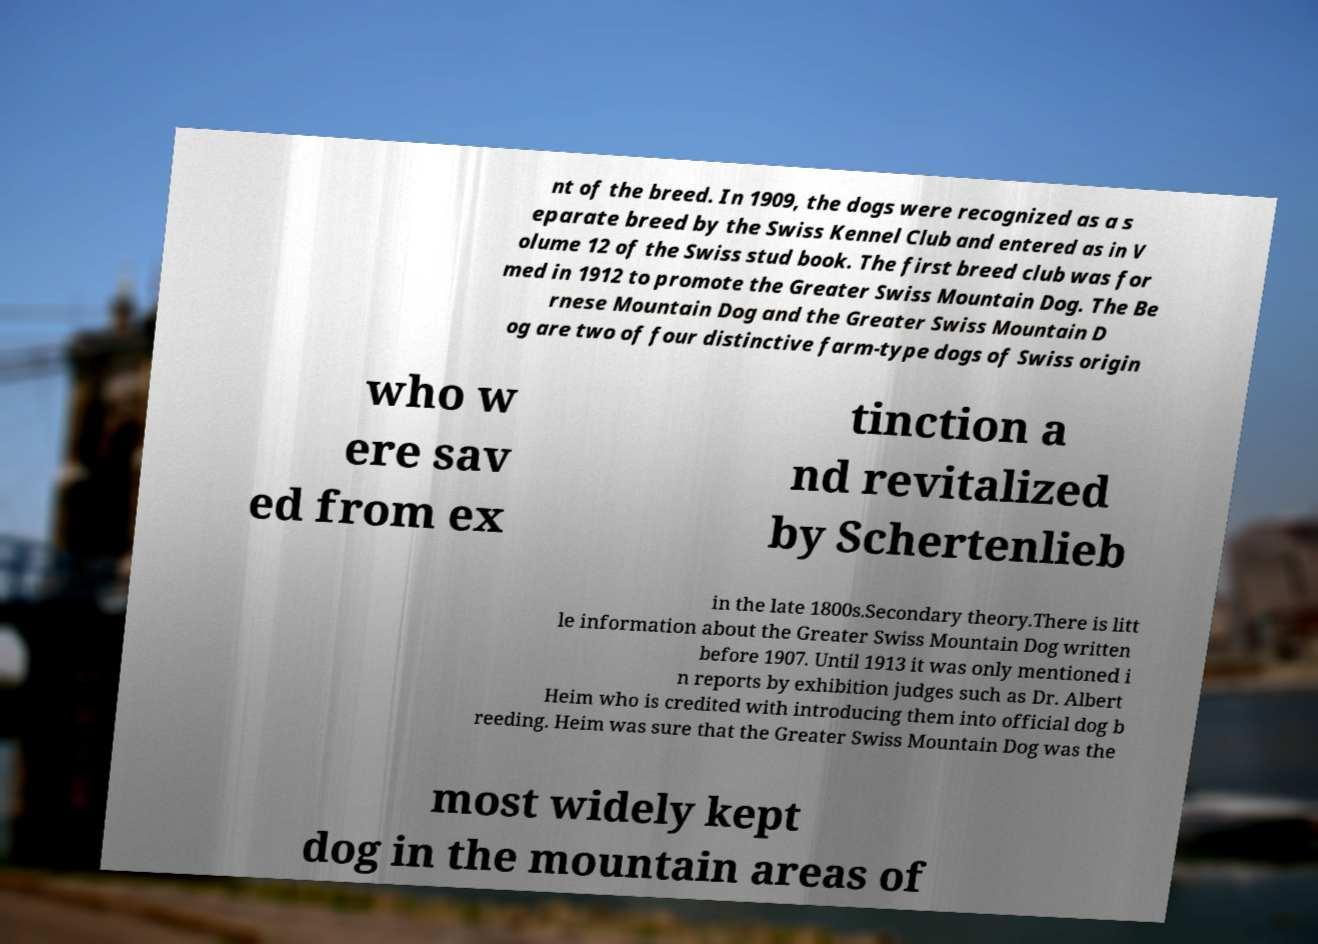Please identify and transcribe the text found in this image. nt of the breed. In 1909, the dogs were recognized as a s eparate breed by the Swiss Kennel Club and entered as in V olume 12 of the Swiss stud book. The first breed club was for med in 1912 to promote the Greater Swiss Mountain Dog. The Be rnese Mountain Dog and the Greater Swiss Mountain D og are two of four distinctive farm-type dogs of Swiss origin who w ere sav ed from ex tinction a nd revitalized by Schertenlieb in the late 1800s.Secondary theory.There is litt le information about the Greater Swiss Mountain Dog written before 1907. Until 1913 it was only mentioned i n reports by exhibition judges such as Dr. Albert Heim who is credited with introducing them into official dog b reeding. Heim was sure that the Greater Swiss Mountain Dog was the most widely kept dog in the mountain areas of 